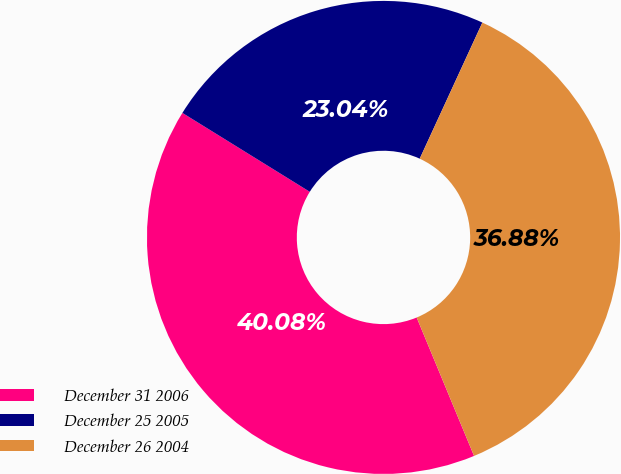<chart> <loc_0><loc_0><loc_500><loc_500><pie_chart><fcel>December 31 2006<fcel>December 25 2005<fcel>December 26 2004<nl><fcel>40.08%<fcel>23.04%<fcel>36.88%<nl></chart> 